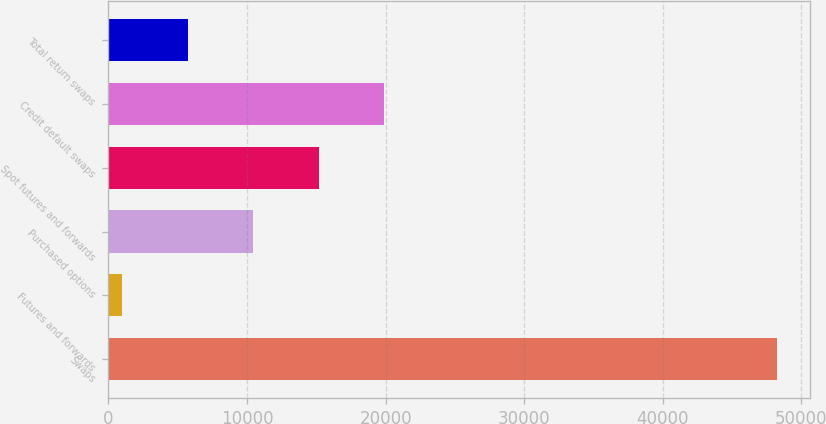Convert chart to OTSL. <chart><loc_0><loc_0><loc_500><loc_500><bar_chart><fcel>Swaps<fcel>Futures and forwards<fcel>Purchased options<fcel>Spot futures and forwards<fcel>Credit default swaps<fcel>Total return swaps<nl><fcel>48225<fcel>1008<fcel>10451.4<fcel>15173.1<fcel>19894.8<fcel>5729.7<nl></chart> 